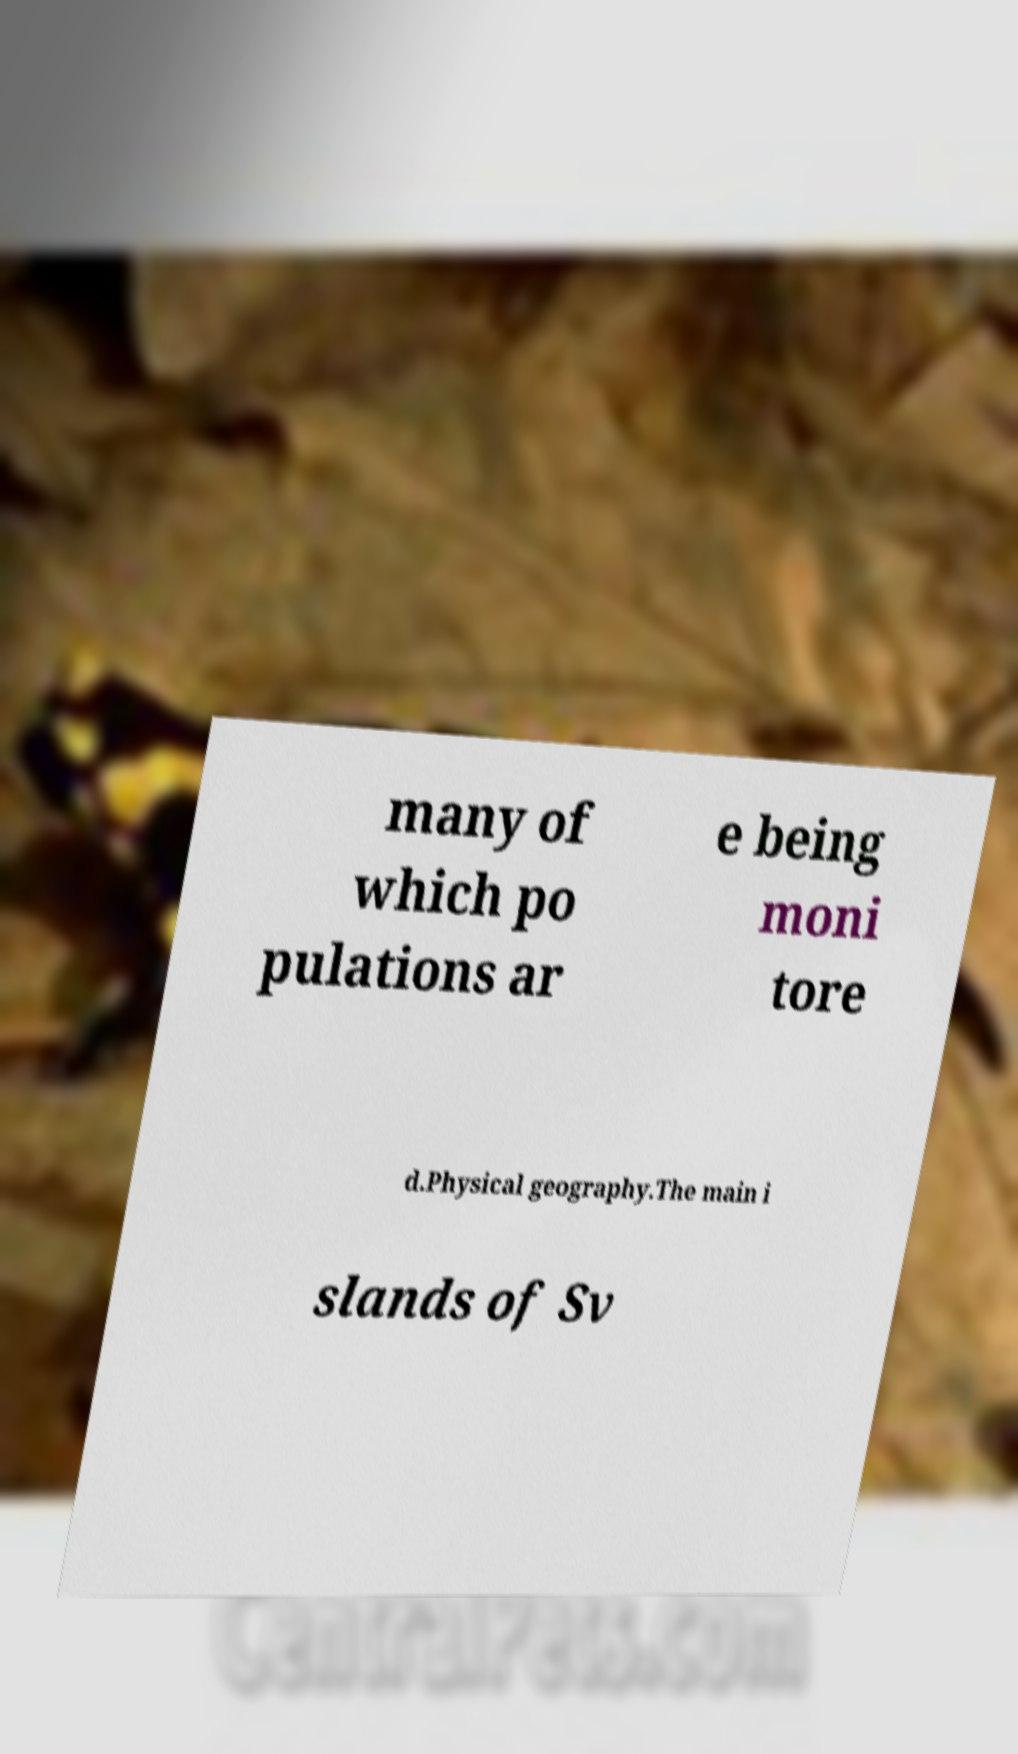I need the written content from this picture converted into text. Can you do that? many of which po pulations ar e being moni tore d.Physical geography.The main i slands of Sv 